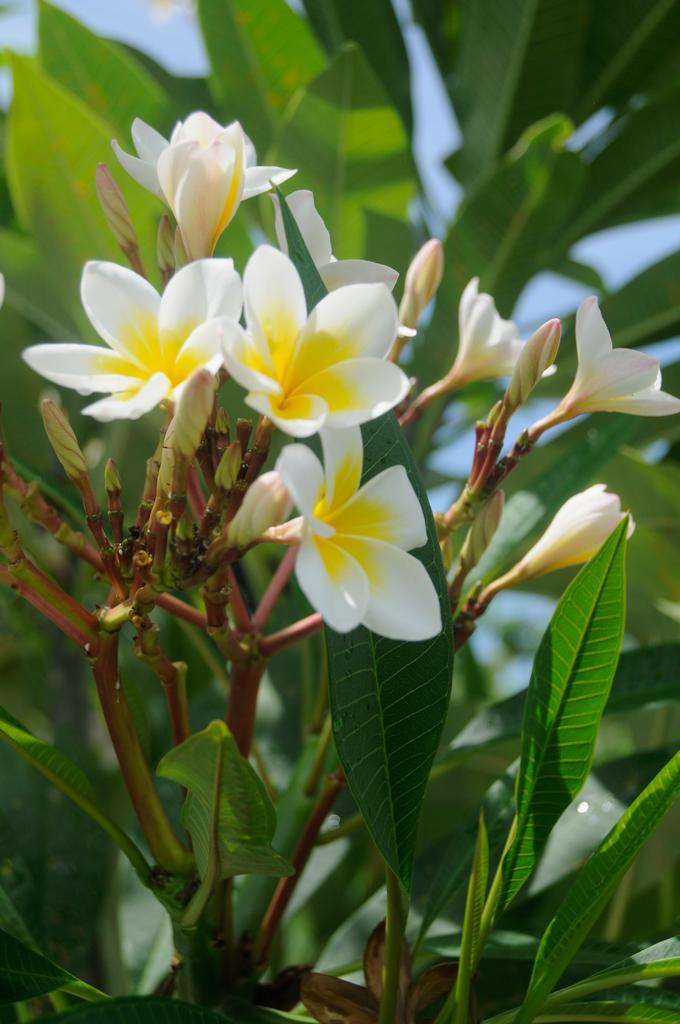What types of living organisms can be seen in the image? Plants and flowers are visible in the image. What stage of growth are some of the plants in? There are buds in the image, which suggests that some of the plants are in the early stages of growth. What is visible behind the plants in the image? The sky is visible behind the plants in the image. What type of ink can be seen dripping from the flowers in the image? There is no ink present in the image; it features plants and flowers with buds. What subject is being taught by the ant in the image? There is no ant present in the image, and therefore no teaching activity can be observed. 